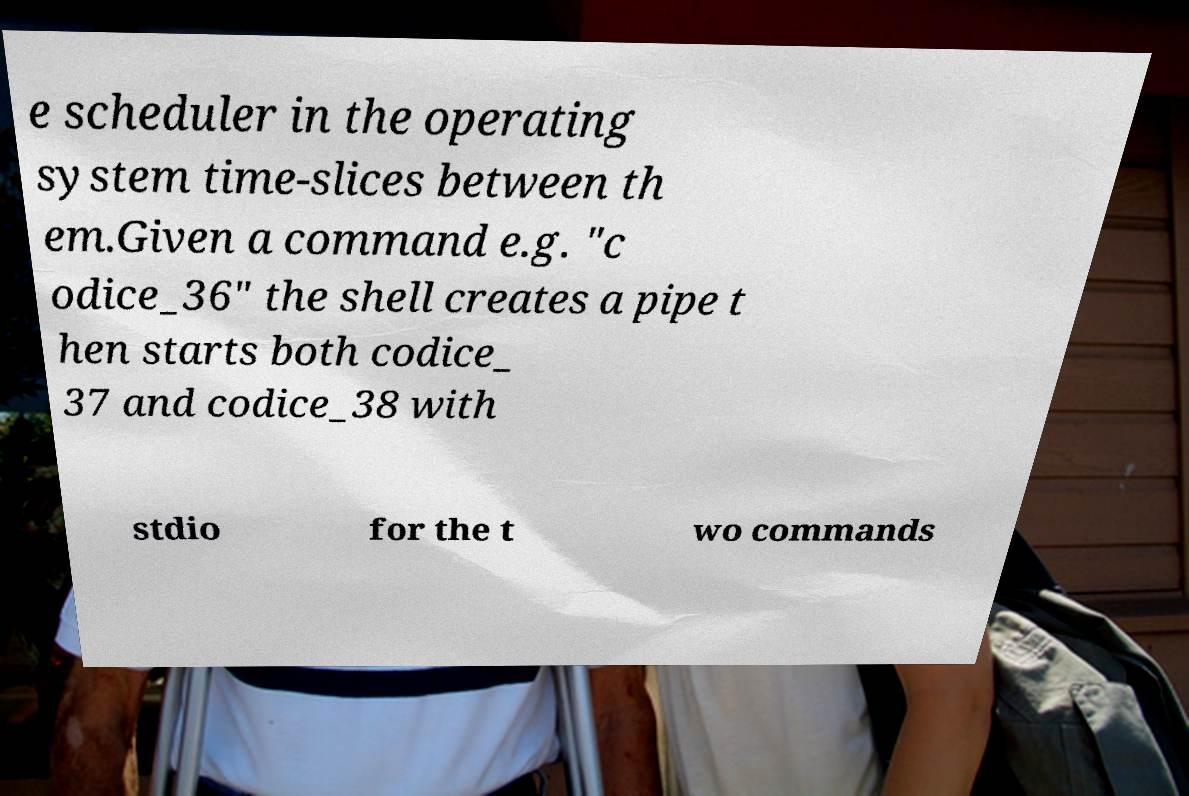I need the written content from this picture converted into text. Can you do that? e scheduler in the operating system time-slices between th em.Given a command e.g. "c odice_36" the shell creates a pipe t hen starts both codice_ 37 and codice_38 with stdio for the t wo commands 